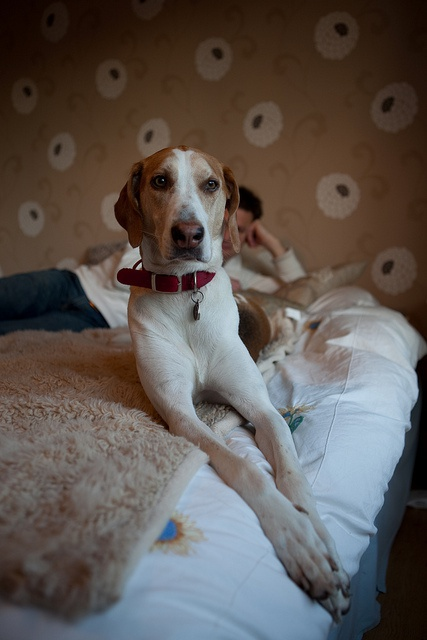Describe the objects in this image and their specific colors. I can see dog in black, darkgray, gray, and maroon tones, bed in black, darkgray, and lightblue tones, bed in black, darkgray, and gray tones, people in black, darkgray, and gray tones, and people in black, gray, and maroon tones in this image. 